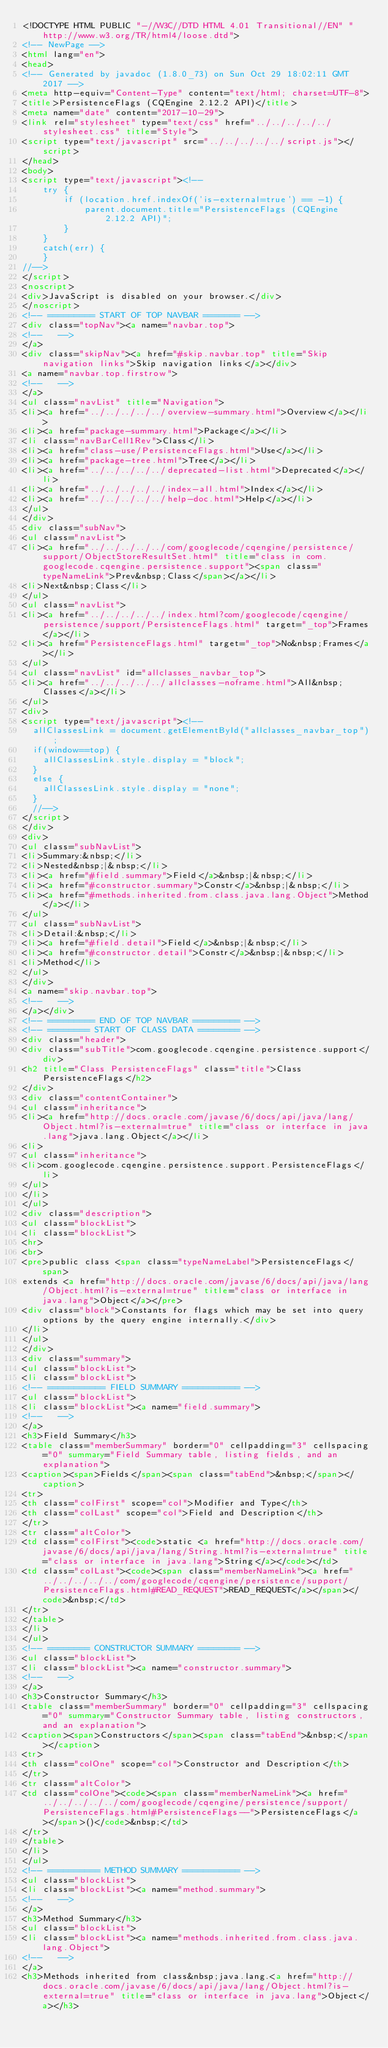<code> <loc_0><loc_0><loc_500><loc_500><_HTML_><!DOCTYPE HTML PUBLIC "-//W3C//DTD HTML 4.01 Transitional//EN" "http://www.w3.org/TR/html4/loose.dtd">
<!-- NewPage -->
<html lang="en">
<head>
<!-- Generated by javadoc (1.8.0_73) on Sun Oct 29 18:02:11 GMT 2017 -->
<meta http-equiv="Content-Type" content="text/html; charset=UTF-8">
<title>PersistenceFlags (CQEngine 2.12.2 API)</title>
<meta name="date" content="2017-10-29">
<link rel="stylesheet" type="text/css" href="../../../../../stylesheet.css" title="Style">
<script type="text/javascript" src="../../../../../script.js"></script>
</head>
<body>
<script type="text/javascript"><!--
    try {
        if (location.href.indexOf('is-external=true') == -1) {
            parent.document.title="PersistenceFlags (CQEngine 2.12.2 API)";
        }
    }
    catch(err) {
    }
//-->
</script>
<noscript>
<div>JavaScript is disabled on your browser.</div>
</noscript>
<!-- ========= START OF TOP NAVBAR ======= -->
<div class="topNav"><a name="navbar.top">
<!--   -->
</a>
<div class="skipNav"><a href="#skip.navbar.top" title="Skip navigation links">Skip navigation links</a></div>
<a name="navbar.top.firstrow">
<!--   -->
</a>
<ul class="navList" title="Navigation">
<li><a href="../../../../../overview-summary.html">Overview</a></li>
<li><a href="package-summary.html">Package</a></li>
<li class="navBarCell1Rev">Class</li>
<li><a href="class-use/PersistenceFlags.html">Use</a></li>
<li><a href="package-tree.html">Tree</a></li>
<li><a href="../../../../../deprecated-list.html">Deprecated</a></li>
<li><a href="../../../../../index-all.html">Index</a></li>
<li><a href="../../../../../help-doc.html">Help</a></li>
</ul>
</div>
<div class="subNav">
<ul class="navList">
<li><a href="../../../../../com/googlecode/cqengine/persistence/support/ObjectStoreResultSet.html" title="class in com.googlecode.cqengine.persistence.support"><span class="typeNameLink">Prev&nbsp;Class</span></a></li>
<li>Next&nbsp;Class</li>
</ul>
<ul class="navList">
<li><a href="../../../../../index.html?com/googlecode/cqengine/persistence/support/PersistenceFlags.html" target="_top">Frames</a></li>
<li><a href="PersistenceFlags.html" target="_top">No&nbsp;Frames</a></li>
</ul>
<ul class="navList" id="allclasses_navbar_top">
<li><a href="../../../../../allclasses-noframe.html">All&nbsp;Classes</a></li>
</ul>
<div>
<script type="text/javascript"><!--
  allClassesLink = document.getElementById("allclasses_navbar_top");
  if(window==top) {
    allClassesLink.style.display = "block";
  }
  else {
    allClassesLink.style.display = "none";
  }
  //-->
</script>
</div>
<div>
<ul class="subNavList">
<li>Summary:&nbsp;</li>
<li>Nested&nbsp;|&nbsp;</li>
<li><a href="#field.summary">Field</a>&nbsp;|&nbsp;</li>
<li><a href="#constructor.summary">Constr</a>&nbsp;|&nbsp;</li>
<li><a href="#methods.inherited.from.class.java.lang.Object">Method</a></li>
</ul>
<ul class="subNavList">
<li>Detail:&nbsp;</li>
<li><a href="#field.detail">Field</a>&nbsp;|&nbsp;</li>
<li><a href="#constructor.detail">Constr</a>&nbsp;|&nbsp;</li>
<li>Method</li>
</ul>
</div>
<a name="skip.navbar.top">
<!--   -->
</a></div>
<!-- ========= END OF TOP NAVBAR ========= -->
<!-- ======== START OF CLASS DATA ======== -->
<div class="header">
<div class="subTitle">com.googlecode.cqengine.persistence.support</div>
<h2 title="Class PersistenceFlags" class="title">Class PersistenceFlags</h2>
</div>
<div class="contentContainer">
<ul class="inheritance">
<li><a href="http://docs.oracle.com/javase/6/docs/api/java/lang/Object.html?is-external=true" title="class or interface in java.lang">java.lang.Object</a></li>
<li>
<ul class="inheritance">
<li>com.googlecode.cqengine.persistence.support.PersistenceFlags</li>
</ul>
</li>
</ul>
<div class="description">
<ul class="blockList">
<li class="blockList">
<hr>
<br>
<pre>public class <span class="typeNameLabel">PersistenceFlags</span>
extends <a href="http://docs.oracle.com/javase/6/docs/api/java/lang/Object.html?is-external=true" title="class or interface in java.lang">Object</a></pre>
<div class="block">Constants for flags which may be set into query options by the query engine internally.</div>
</li>
</ul>
</div>
<div class="summary">
<ul class="blockList">
<li class="blockList">
<!-- =========== FIELD SUMMARY =========== -->
<ul class="blockList">
<li class="blockList"><a name="field.summary">
<!--   -->
</a>
<h3>Field Summary</h3>
<table class="memberSummary" border="0" cellpadding="3" cellspacing="0" summary="Field Summary table, listing fields, and an explanation">
<caption><span>Fields</span><span class="tabEnd">&nbsp;</span></caption>
<tr>
<th class="colFirst" scope="col">Modifier and Type</th>
<th class="colLast" scope="col">Field and Description</th>
</tr>
<tr class="altColor">
<td class="colFirst"><code>static <a href="http://docs.oracle.com/javase/6/docs/api/java/lang/String.html?is-external=true" title="class or interface in java.lang">String</a></code></td>
<td class="colLast"><code><span class="memberNameLink"><a href="../../../../../com/googlecode/cqengine/persistence/support/PersistenceFlags.html#READ_REQUEST">READ_REQUEST</a></span></code>&nbsp;</td>
</tr>
</table>
</li>
</ul>
<!-- ======== CONSTRUCTOR SUMMARY ======== -->
<ul class="blockList">
<li class="blockList"><a name="constructor.summary">
<!--   -->
</a>
<h3>Constructor Summary</h3>
<table class="memberSummary" border="0" cellpadding="3" cellspacing="0" summary="Constructor Summary table, listing constructors, and an explanation">
<caption><span>Constructors</span><span class="tabEnd">&nbsp;</span></caption>
<tr>
<th class="colOne" scope="col">Constructor and Description</th>
</tr>
<tr class="altColor">
<td class="colOne"><code><span class="memberNameLink"><a href="../../../../../com/googlecode/cqengine/persistence/support/PersistenceFlags.html#PersistenceFlags--">PersistenceFlags</a></span>()</code>&nbsp;</td>
</tr>
</table>
</li>
</ul>
<!-- ========== METHOD SUMMARY =========== -->
<ul class="blockList">
<li class="blockList"><a name="method.summary">
<!--   -->
</a>
<h3>Method Summary</h3>
<ul class="blockList">
<li class="blockList"><a name="methods.inherited.from.class.java.lang.Object">
<!--   -->
</a>
<h3>Methods inherited from class&nbsp;java.lang.<a href="http://docs.oracle.com/javase/6/docs/api/java/lang/Object.html?is-external=true" title="class or interface in java.lang">Object</a></h3></code> 